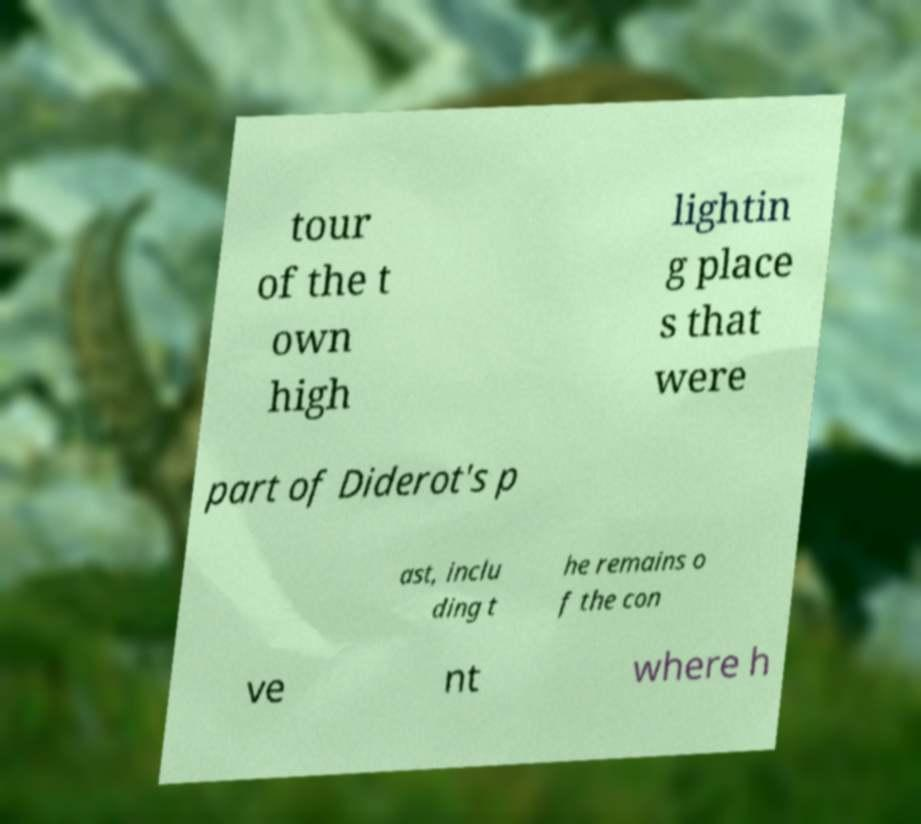Please identify and transcribe the text found in this image. tour of the t own high lightin g place s that were part of Diderot's p ast, inclu ding t he remains o f the con ve nt where h 